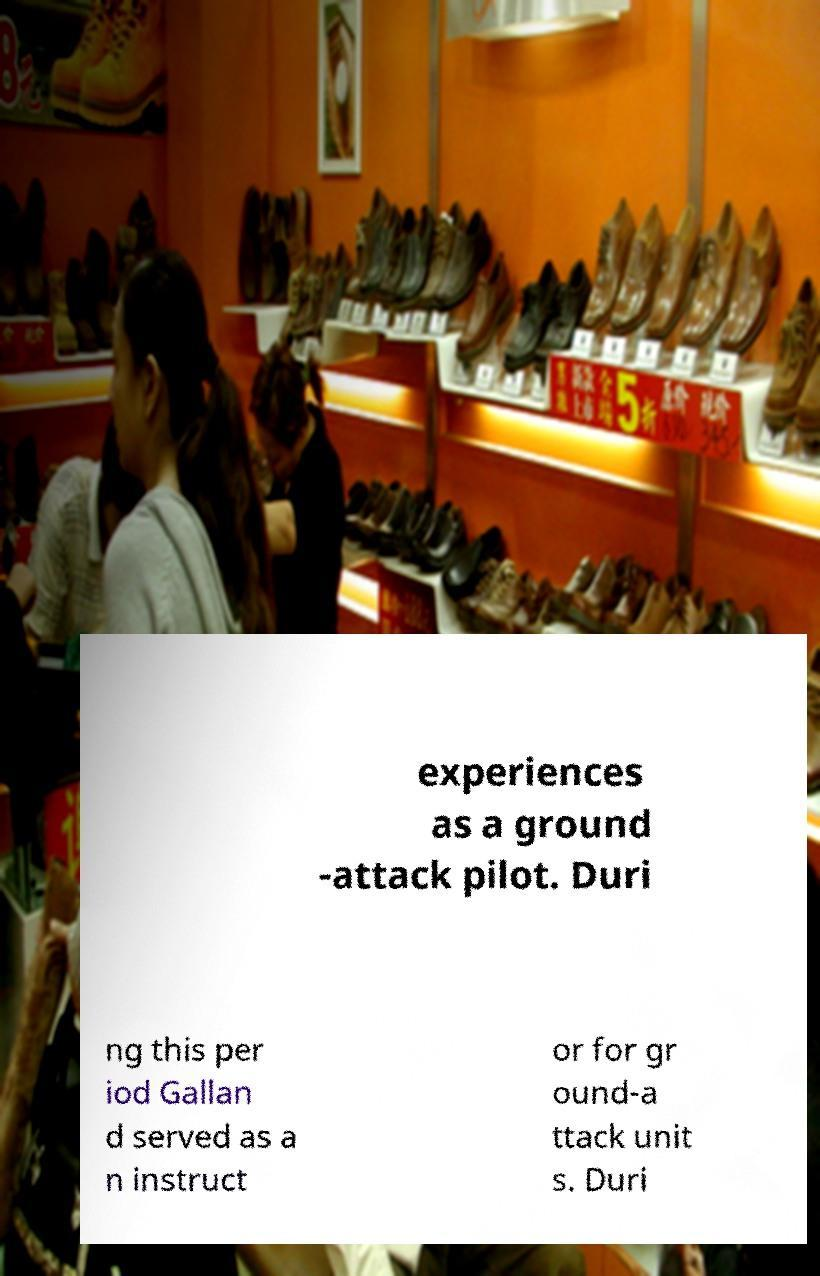Can you read and provide the text displayed in the image?This photo seems to have some interesting text. Can you extract and type it out for me? experiences as a ground -attack pilot. Duri ng this per iod Gallan d served as a n instruct or for gr ound-a ttack unit s. Duri 